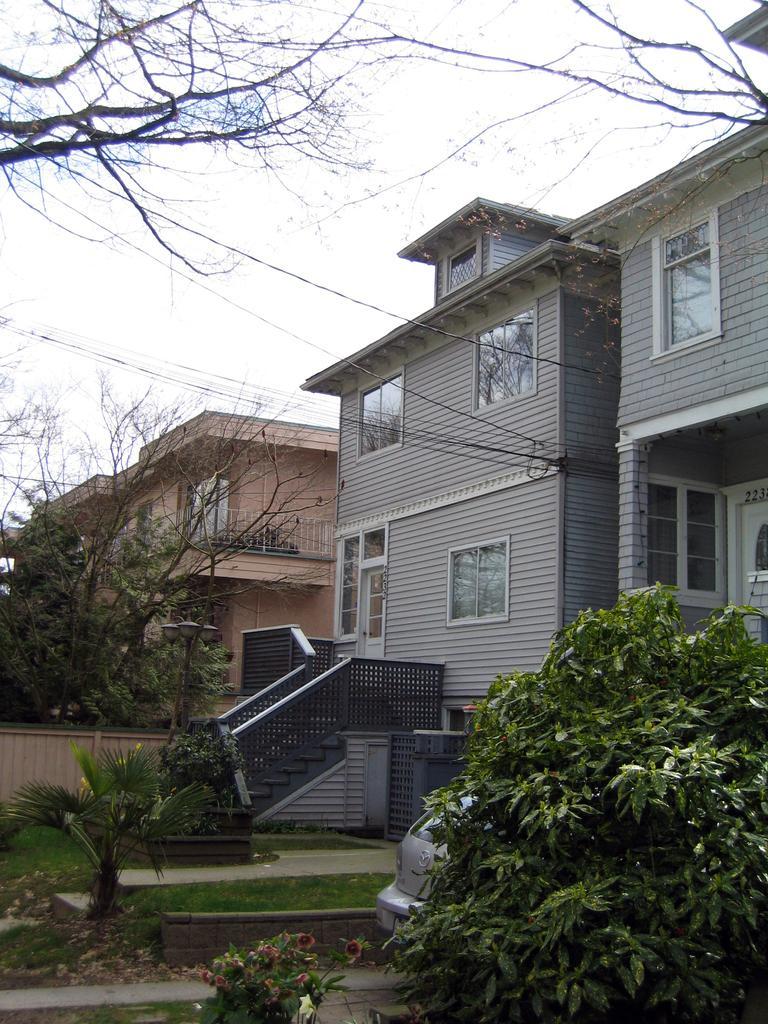Can you describe this image briefly? In the picture I can see the houses and glass windows. I can see the staircase of the house and trees. There is a car parked on the right side. I can see the electric wires. I can see the flowering plant at the bottom of the picture. 